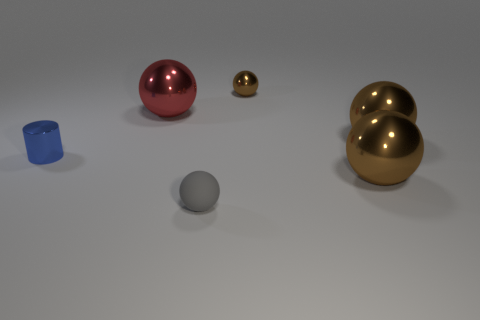Are there any other things that are the same material as the gray sphere?
Your response must be concise. No. Is there any other thing that has the same shape as the tiny blue thing?
Offer a very short reply. No. How many objects are either large red spheres or large brown shiny objects in front of the small blue shiny thing?
Make the answer very short. 2. How many other things are the same color as the small metallic cylinder?
Your answer should be very brief. 0. What number of red objects are either small matte balls or large metal balls?
Offer a very short reply. 1. There is a tiny ball in front of the small brown ball on the right side of the tiny blue shiny object; is there a small blue shiny cylinder to the right of it?
Offer a terse response. No. Is there anything else that has the same size as the red metal sphere?
Keep it short and to the point. Yes. Is the tiny matte ball the same color as the small metallic ball?
Keep it short and to the point. No. What color is the tiny sphere that is to the left of the small sphere behind the tiny rubber thing?
Provide a short and direct response. Gray. What number of big objects are shiny balls or purple metallic cylinders?
Ensure brevity in your answer.  3. 